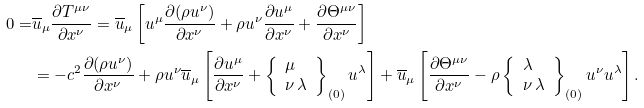Convert formula to latex. <formula><loc_0><loc_0><loc_500><loc_500>0 = & \overline { u } _ { \mu } \frac { \partial T ^ { \mu \nu } } { \partial x ^ { \nu } } = \overline { u } _ { \mu } \left [ u ^ { \mu } \frac { \partial ( \rho u ^ { \nu } ) } { \partial x ^ { \nu } } + \rho u ^ { \nu } \frac { \partial u ^ { \mu } } { \partial x ^ { \nu } } + \frac { \partial \Theta ^ { \mu \nu } } { \partial x ^ { \nu } } \right ] \\ & = - c ^ { 2 } \frac { \partial ( \rho u ^ { \nu } ) } { \partial x ^ { \nu } } + \rho u ^ { \nu } \overline { u } _ { \mu } \left [ \frac { \partial u ^ { \mu } } { \partial x ^ { \nu } } + \left \{ \begin{array} { l } \mu \\ \nu \, \lambda \end{array} \right \} _ { ( 0 ) } u ^ { \lambda } \right ] + \overline { u } _ { \mu } \left [ \frac { \partial \Theta ^ { \mu \nu } } { \partial x ^ { \nu } } - \rho \left \{ \begin{array} { l } \lambda \\ \nu \, \lambda \end{array} \right \} _ { ( 0 ) } u ^ { \nu } u ^ { \lambda } \right ] .</formula> 